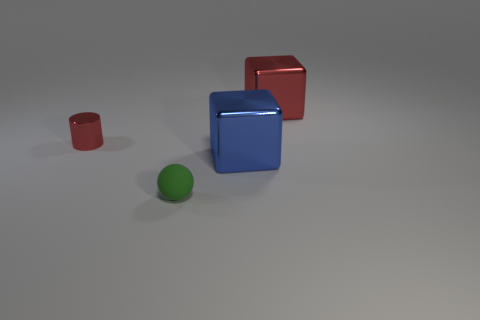Add 1 green matte balls. How many objects exist? 5 Subtract all spheres. How many objects are left? 3 Subtract 0 brown balls. How many objects are left? 4 Subtract all tiny cyan metallic things. Subtract all blue shiny objects. How many objects are left? 3 Add 2 big red shiny objects. How many big red shiny objects are left? 3 Add 2 cyan metal objects. How many cyan metal objects exist? 2 